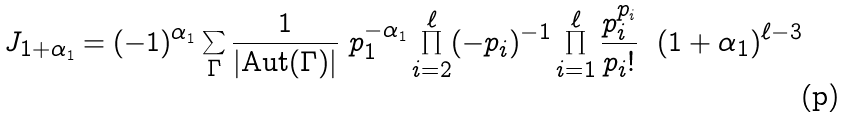<formula> <loc_0><loc_0><loc_500><loc_500>J _ { 1 + \alpha _ { 1 } } = ( - 1 ) ^ { \alpha _ { 1 } } \sum _ { \Gamma } \frac { 1 } { | \text {Aut} ( \Gamma ) | } \ p _ { 1 } ^ { - \alpha _ { 1 } } \prod _ { i = 2 } ^ { \ell } ( - p _ { i } ) ^ { - 1 } \prod _ { i = 1 } ^ { \ell } \frac { p _ { i } ^ { p _ { i } } } { p _ { i } ! } \ \ ( 1 + \alpha _ { 1 } ) ^ { \ell - 3 } \</formula> 